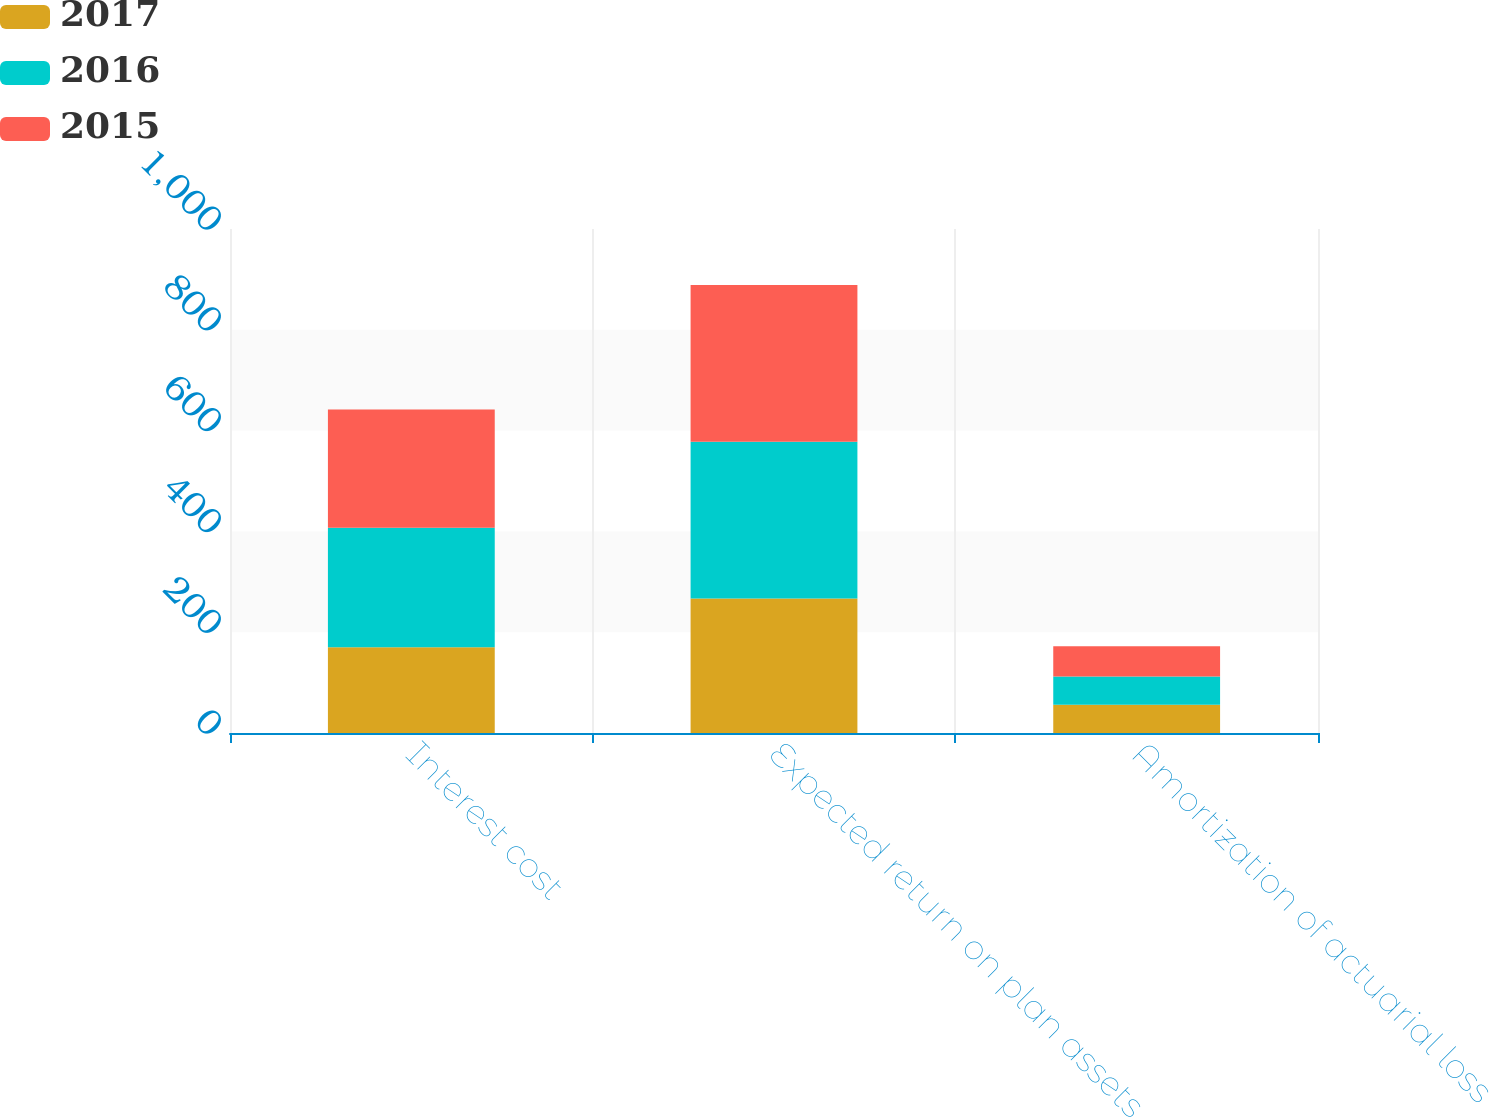<chart> <loc_0><loc_0><loc_500><loc_500><stacked_bar_chart><ecel><fcel>Interest cost<fcel>Expected return on plan assets<fcel>Amortization of actuarial loss<nl><fcel>2017<fcel>170<fcel>267<fcel>56<nl><fcel>2016<fcel>237<fcel>311<fcel>56<nl><fcel>2015<fcel>235<fcel>311<fcel>60<nl></chart> 